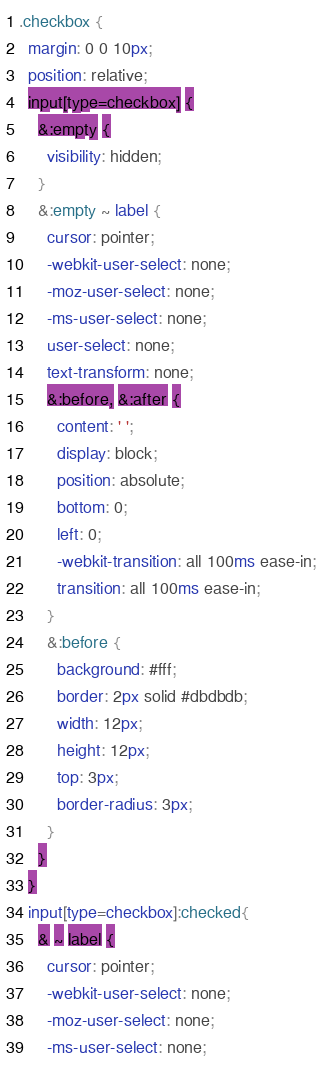Convert code to text. <code><loc_0><loc_0><loc_500><loc_500><_CSS_>.checkbox {
  margin: 0 0 10px;
  position: relative;
  input[type=checkbox] {
    &:empty {
      visibility: hidden;
    }
    &:empty ~ label {
      cursor: pointer;
      -webkit-user-select: none;
      -moz-user-select: none;
      -ms-user-select: none;
      user-select: none;
      text-transform: none;
      &:before, &:after {
        content: ' ';
        display: block;
        position: absolute;
        bottom: 0;
        left: 0;
        -webkit-transition: all 100ms ease-in;
        transition: all 100ms ease-in;
      }
      &:before {
        background: #fff;
        border: 2px solid #dbdbdb;
        width: 12px;
        height: 12px;
        top: 3px;
        border-radius: 3px;
      }
    }
  }
  input[type=checkbox]:checked{
    & ~ label {
      cursor: pointer;
      -webkit-user-select: none;
      -moz-user-select: none;
      -ms-user-select: none;</code> 